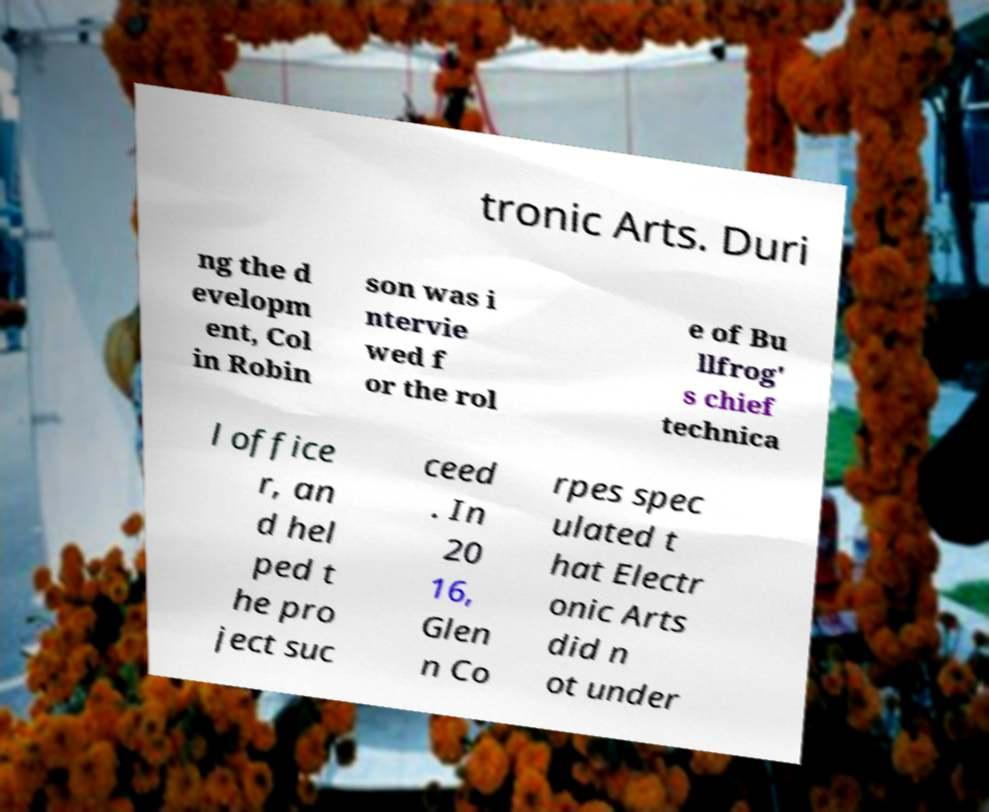For documentation purposes, I need the text within this image transcribed. Could you provide that? tronic Arts. Duri ng the d evelopm ent, Col in Robin son was i ntervie wed f or the rol e of Bu llfrog' s chief technica l office r, an d hel ped t he pro ject suc ceed . In 20 16, Glen n Co rpes spec ulated t hat Electr onic Arts did n ot under 